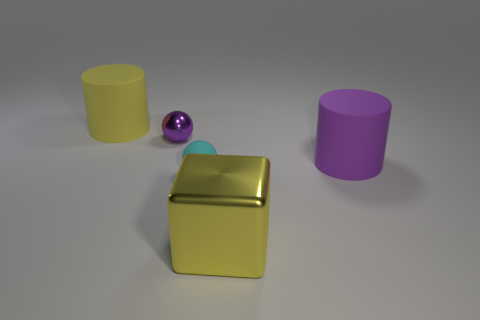Add 2 small purple objects. How many objects exist? 7 Subtract all cylinders. How many objects are left? 3 Subtract all small blue metal balls. Subtract all cyan matte spheres. How many objects are left? 4 Add 5 matte balls. How many matte balls are left? 6 Add 2 large yellow cylinders. How many large yellow cylinders exist? 3 Subtract 1 yellow blocks. How many objects are left? 4 